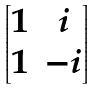Convert formula to latex. <formula><loc_0><loc_0><loc_500><loc_500>\begin{bmatrix} 1 & i \\ 1 & - i \end{bmatrix}</formula> 